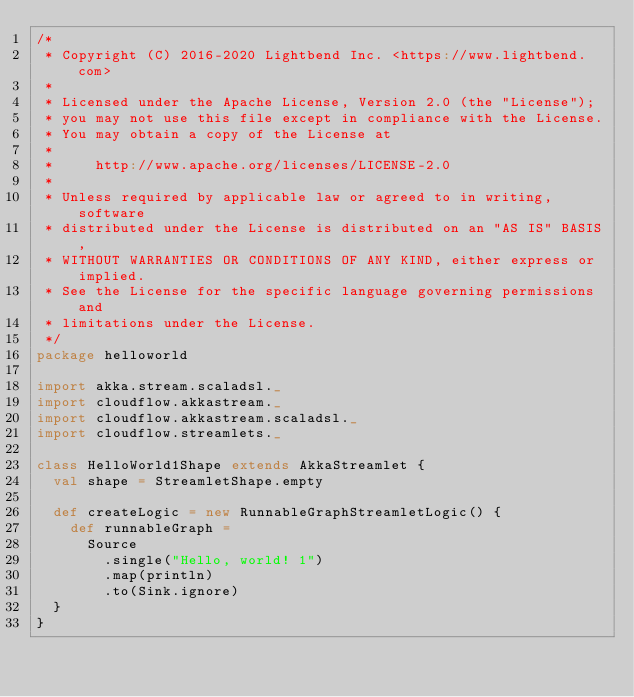<code> <loc_0><loc_0><loc_500><loc_500><_Scala_>/*
 * Copyright (C) 2016-2020 Lightbend Inc. <https://www.lightbend.com>
 *
 * Licensed under the Apache License, Version 2.0 (the "License");
 * you may not use this file except in compliance with the License.
 * You may obtain a copy of the License at
 *
 *     http://www.apache.org/licenses/LICENSE-2.0
 *
 * Unless required by applicable law or agreed to in writing, software
 * distributed under the License is distributed on an "AS IS" BASIS,
 * WITHOUT WARRANTIES OR CONDITIONS OF ANY KIND, either express or implied.
 * See the License for the specific language governing permissions and
 * limitations under the License.
 */
package helloworld

import akka.stream.scaladsl._
import cloudflow.akkastream._
import cloudflow.akkastream.scaladsl._
import cloudflow.streamlets._

class HelloWorld1Shape extends AkkaStreamlet {
  val shape = StreamletShape.empty

  def createLogic = new RunnableGraphStreamletLogic() {
    def runnableGraph = 
      Source
        .single("Hello, world! 1")
        .map(println)
        .to(Sink.ignore)
  }
}

</code> 